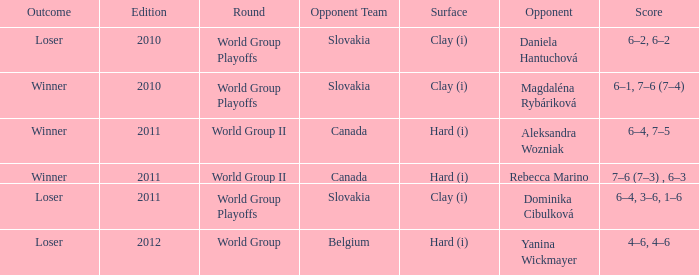What transpired in the game when the competitor was magdaléna rybáriková? Winner. 